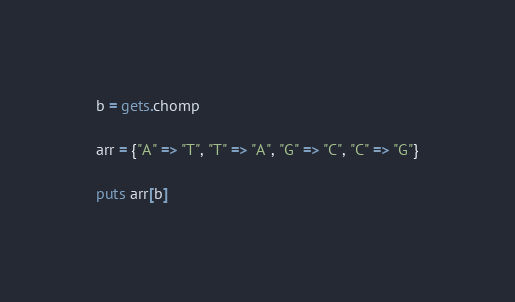<code> <loc_0><loc_0><loc_500><loc_500><_Ruby_>b = gets.chomp
 
arr = {"A" => "T", "T" => "A", "G" => "C", "C" => "G"}
 
puts arr[b]</code> 